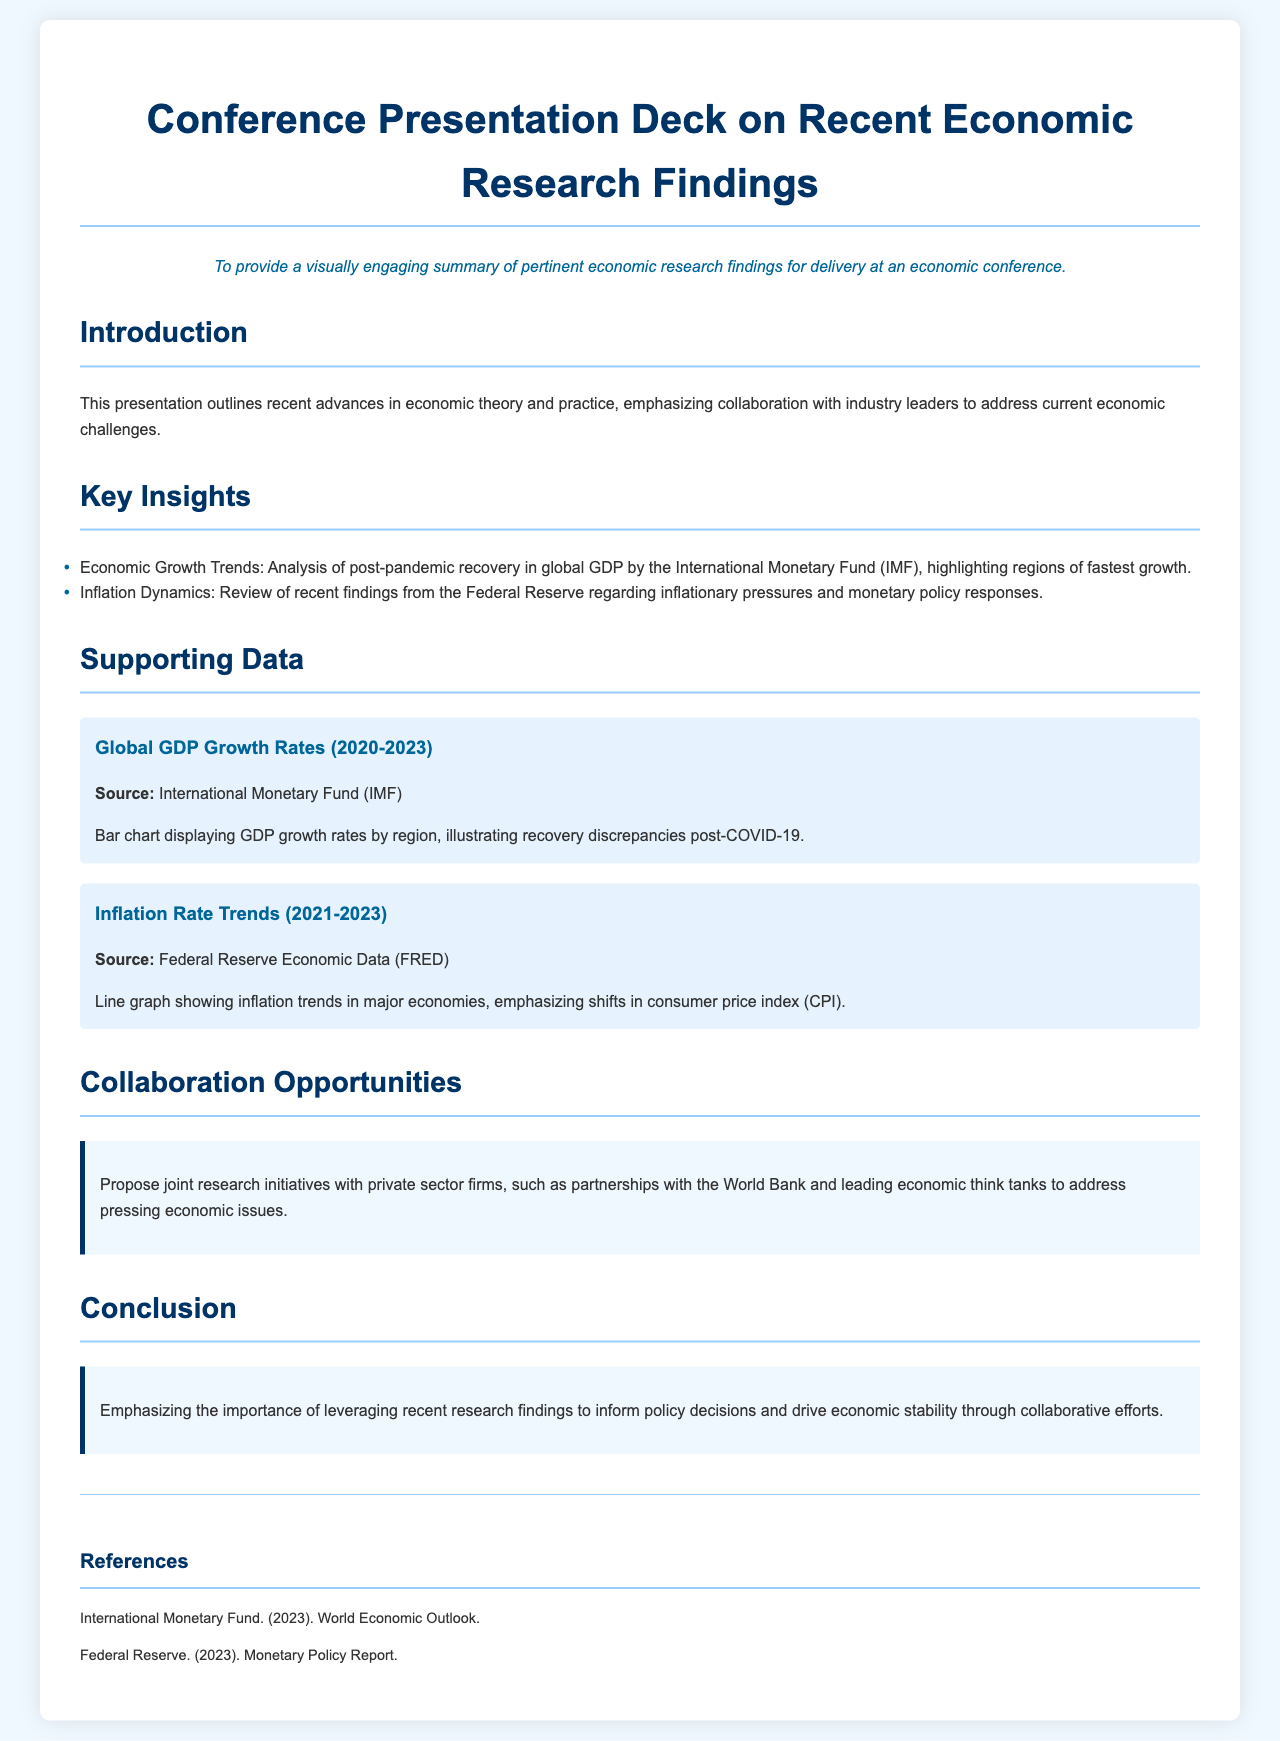What is the title of the presentation? The title is provided in the document's header section.
Answer: Conference Presentation Deck on Recent Economic Research Findings What is the objective of the presentation? The objective outlines the purpose of the presentation and is mentioned prominently after the title.
Answer: To provide a visually engaging summary of pertinent economic research findings for delivery at an economic conference Which institution's analysis is referenced for Economic Growth Trends? The document specifies the source of the analysis in the Key Insights section.
Answer: International Monetary Fund (IMF) What years are represented in the Global GDP Growth Rates chart? The years are typically indicated in the chart header or nearby content.
Answer: 2020-2023 What are the collaboration opportunities mentioned? The collaboration section describes potential partnerships to address economic issues.
Answer: Joint research initiatives with private sector firms Which two sources are cited in the references? The references section lists the sources used for the data and insights in the presentation.
Answer: International Monetary Fund and Federal Reserve What is the primary focus of the Inflation Rate Trends chart? The document provides details about the emphasis of the chart in the Supporting Data section.
Answer: Shifts in consumer price index (CPI) How does the document propose addressing pressing economic issues? The collaboration opportunities discuss proposed methods for addressing economic challenges.
Answer: Partnerships with the World Bank and leading economic think tanks 